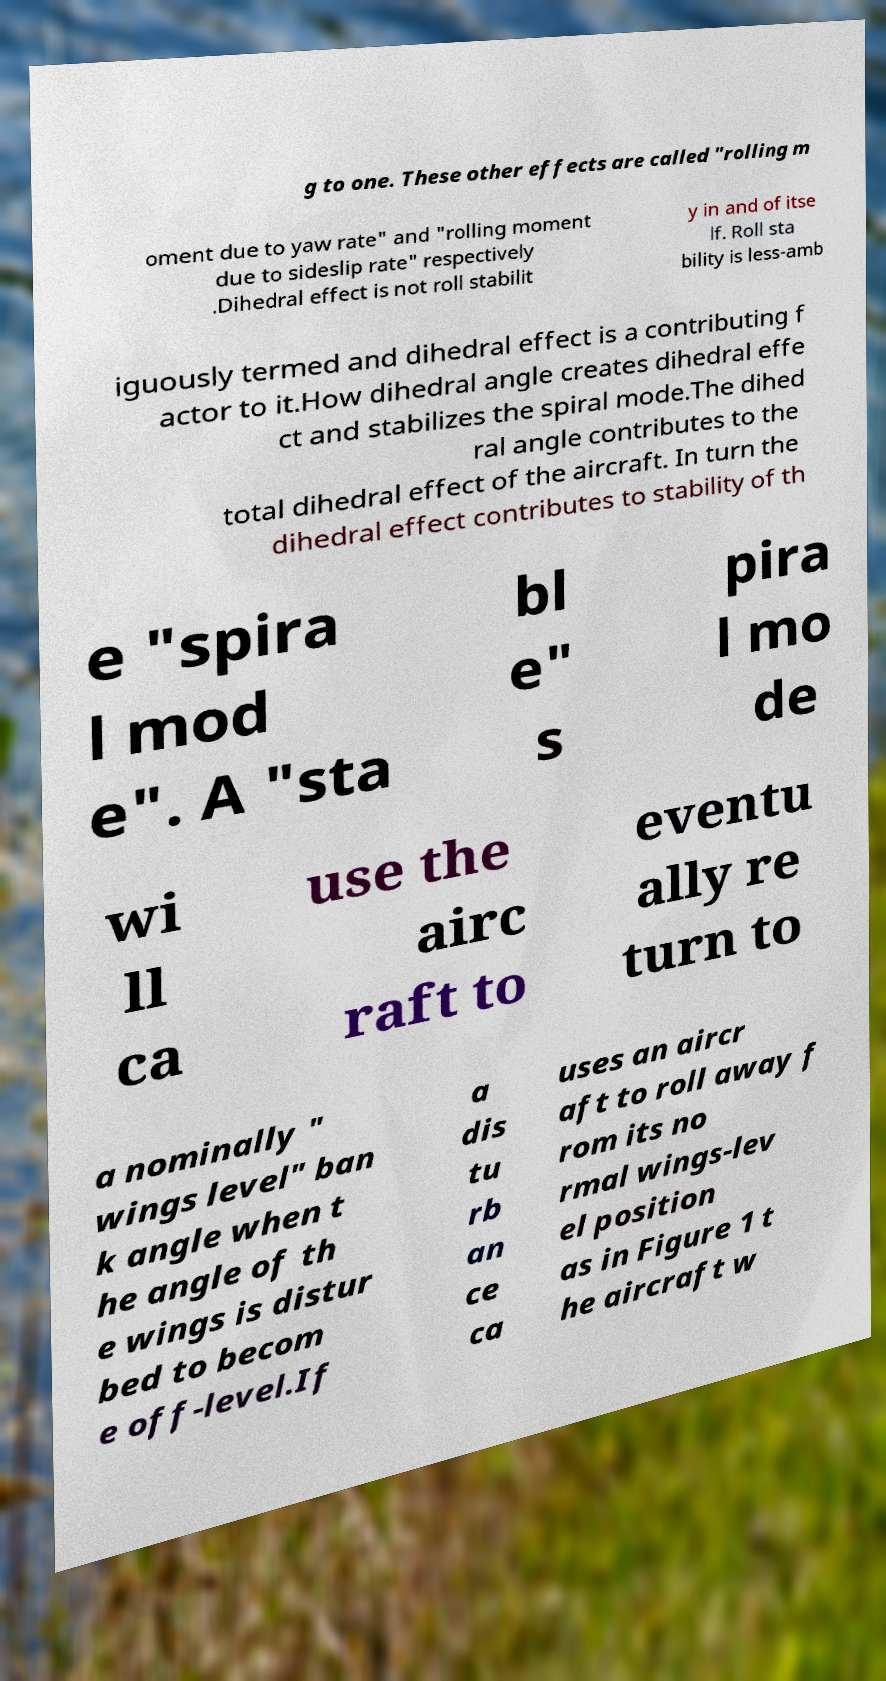I need the written content from this picture converted into text. Can you do that? g to one. These other effects are called "rolling m oment due to yaw rate" and "rolling moment due to sideslip rate" respectively .Dihedral effect is not roll stabilit y in and of itse lf. Roll sta bility is less-amb iguously termed and dihedral effect is a contributing f actor to it.How dihedral angle creates dihedral effe ct and stabilizes the spiral mode.The dihed ral angle contributes to the total dihedral effect of the aircraft. In turn the dihedral effect contributes to stability of th e "spira l mod e". A "sta bl e" s pira l mo de wi ll ca use the airc raft to eventu ally re turn to a nominally " wings level" ban k angle when t he angle of th e wings is distur bed to becom e off-level.If a dis tu rb an ce ca uses an aircr aft to roll away f rom its no rmal wings-lev el position as in Figure 1 t he aircraft w 